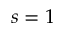Convert formula to latex. <formula><loc_0><loc_0><loc_500><loc_500>s = 1</formula> 